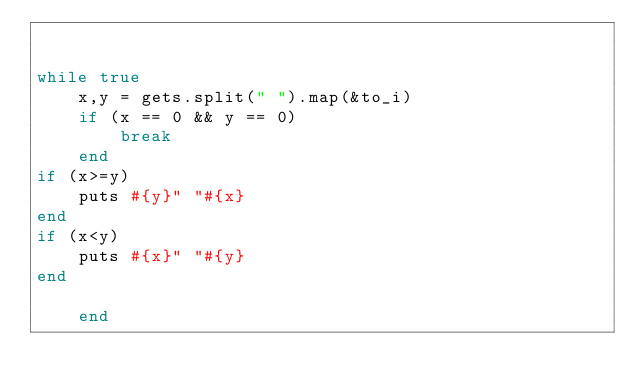<code> <loc_0><loc_0><loc_500><loc_500><_Ruby_>

while true
	x,y = gets.split(" ").map(&to_i)
	if (x == 0 && y == 0)
		break
	end
if (x>=y)
	puts #{y}" "#{x}
end
if (x<y)
	puts #{x}" "#{y}
end
		
	end </code> 